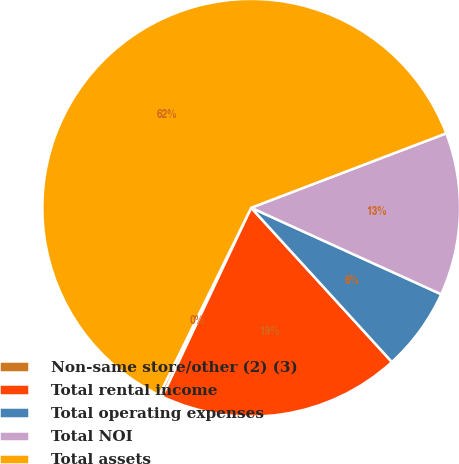<chart> <loc_0><loc_0><loc_500><loc_500><pie_chart><fcel>Non-same store/other (2) (3)<fcel>Total rental income<fcel>Total operating expenses<fcel>Total NOI<fcel>Total assets<nl><fcel>0.26%<fcel>18.77%<fcel>6.43%<fcel>12.6%<fcel>61.94%<nl></chart> 